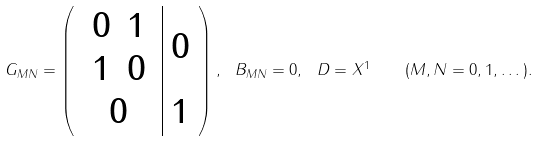Convert formula to latex. <formula><loc_0><loc_0><loc_500><loc_500>G _ { M N } = \left ( \begin{array} { c | c } \begin{array} { c c } 0 & 1 \\ 1 & 0 \end{array} & 0 \\ 0 & { 1 } \end{array} \right ) , \ B _ { M N } = 0 , \ D = X ^ { 1 } \quad ( M , N = 0 , 1 , \dots ) .</formula> 